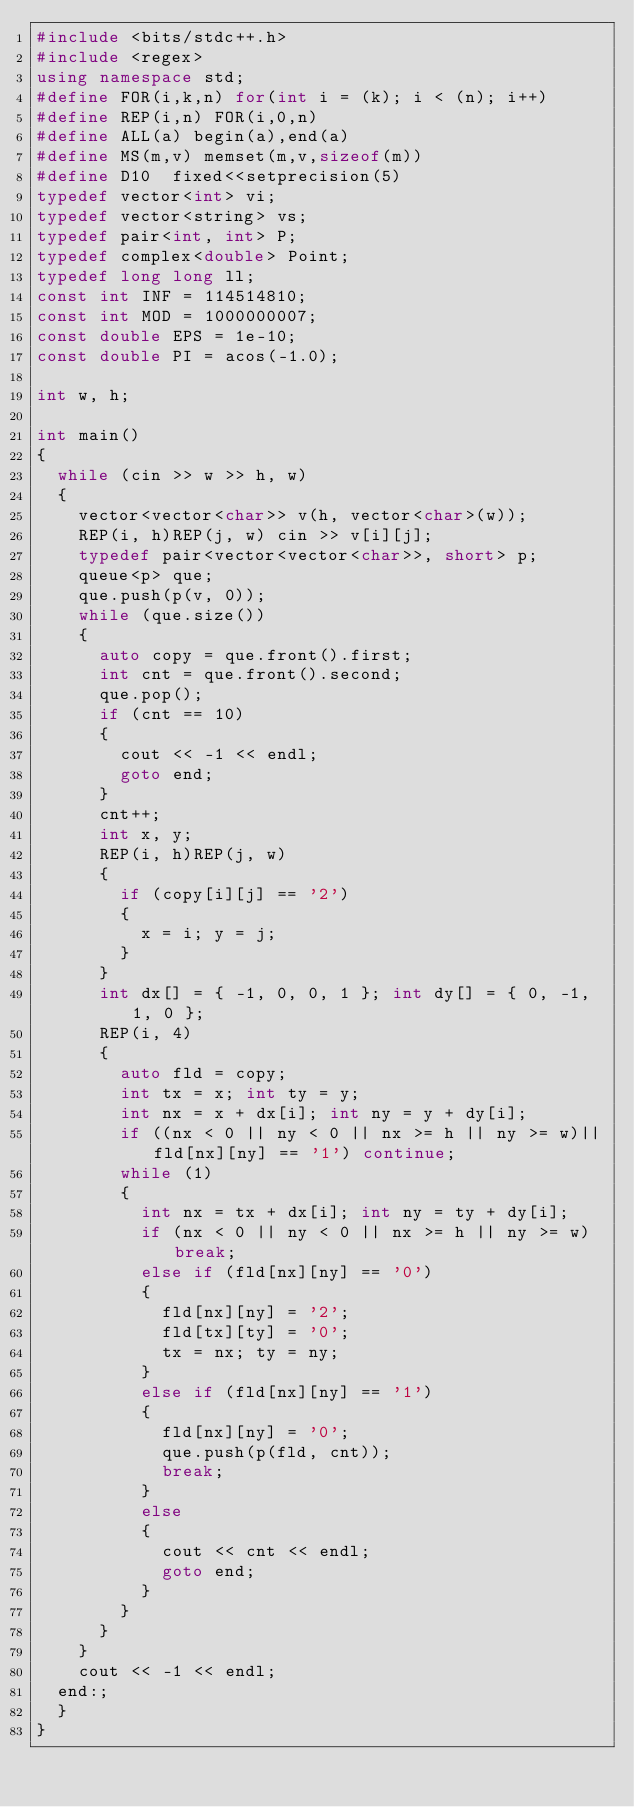Convert code to text. <code><loc_0><loc_0><loc_500><loc_500><_C++_>#include <bits/stdc++.h>
#include <regex>
using namespace std;
#define FOR(i,k,n) for(int i = (k); i < (n); i++)
#define REP(i,n) FOR(i,0,n)
#define ALL(a) begin(a),end(a)
#define MS(m,v) memset(m,v,sizeof(m))
#define D10  fixed<<setprecision(5)
typedef vector<int> vi;
typedef vector<string> vs;
typedef pair<int, int> P;
typedef complex<double> Point;
typedef long long ll;
const int INF = 114514810;
const int MOD = 1000000007;
const double EPS = 1e-10;
const double PI = acos(-1.0);

int w, h;

int main()
{
	while (cin >> w >> h, w)
	{
		vector<vector<char>> v(h, vector<char>(w));
		REP(i, h)REP(j, w) cin >> v[i][j];
		typedef pair<vector<vector<char>>, short> p;
		queue<p> que;
		que.push(p(v, 0));
		while (que.size())
		{
			auto copy = que.front().first;
			int cnt = que.front().second;
			que.pop();
			if (cnt == 10)
			{
				cout << -1 << endl;
				goto end;
			}
			cnt++;
			int x, y;
			REP(i, h)REP(j, w)
			{
				if (copy[i][j] == '2')
				{
					x = i; y = j;
				}
			}
			int dx[] = { -1, 0, 0, 1 }; int dy[] = { 0, -1, 1, 0 };
			REP(i, 4)
			{
				auto fld = copy;
				int tx = x; int ty = y;
				int nx = x + dx[i]; int ny = y + dy[i];
				if ((nx < 0 || ny < 0 || nx >= h || ny >= w)||fld[nx][ny] == '1') continue;
				while (1)
				{
					int nx = tx + dx[i]; int ny = ty + dy[i];
					if (nx < 0 || ny < 0 || nx >= h || ny >= w) break;
					else if (fld[nx][ny] == '0')
					{
						fld[nx][ny] = '2';
						fld[tx][ty] = '0';
						tx = nx; ty = ny;
					}
					else if (fld[nx][ny] == '1')
					{
						fld[nx][ny] = '0';
						que.push(p(fld, cnt));
						break;
					}
					else
					{
						cout << cnt << endl;
						goto end;
					}
				}
			}
		}
		cout << -1 << endl;
	end:;
	}
}</code> 